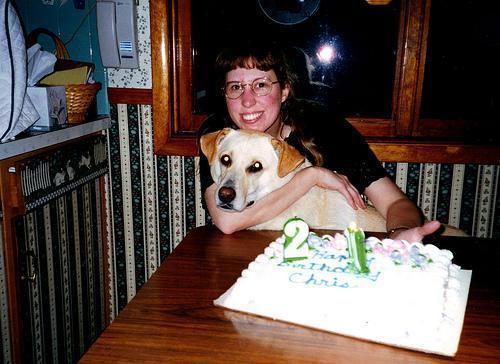How many people in the photo?
Give a very brief answer. 1. 